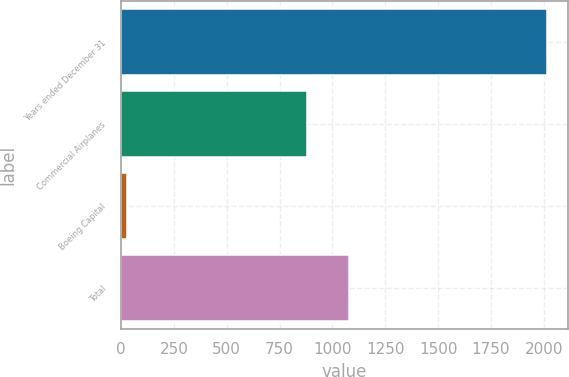Convert chart to OTSL. <chart><loc_0><loc_0><loc_500><loc_500><bar_chart><fcel>Years ended December 31<fcel>Commercial Airplanes<fcel>Boeing Capital<fcel>Total<nl><fcel>2013<fcel>879<fcel>29<fcel>1077.4<nl></chart> 